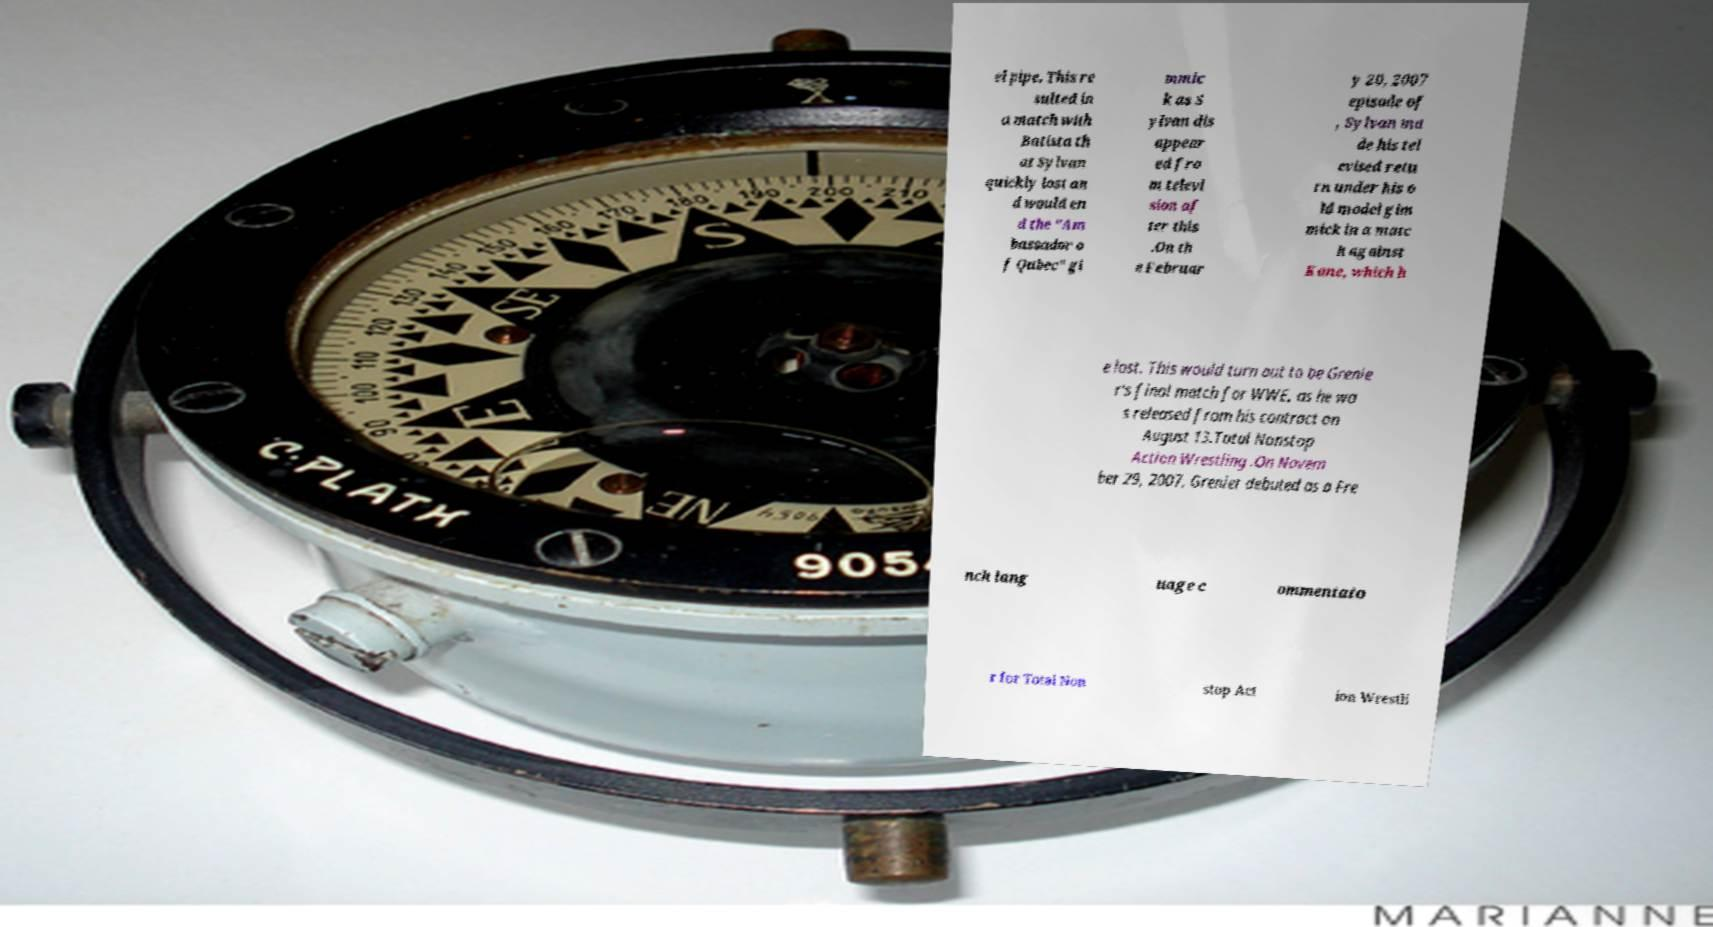Please identify and transcribe the text found in this image. el pipe. This re sulted in a match with Batista th at Sylvan quickly lost an d would en d the "Am bassador o f Qubec" gi mmic k as S ylvan dis appear ed fro m televi sion af ter this .On th e Februar y 20, 2007 episode of , Sylvan ma de his tel evised retu rn under his o ld model gim mick in a matc h against Kane, which h e lost. This would turn out to be Grenie r's final match for WWE, as he wa s released from his contract on August 13.Total Nonstop Action Wrestling .On Novem ber 29, 2007, Grenier debuted as a Fre nch lang uage c ommentato r for Total Non stop Act ion Wrestli 